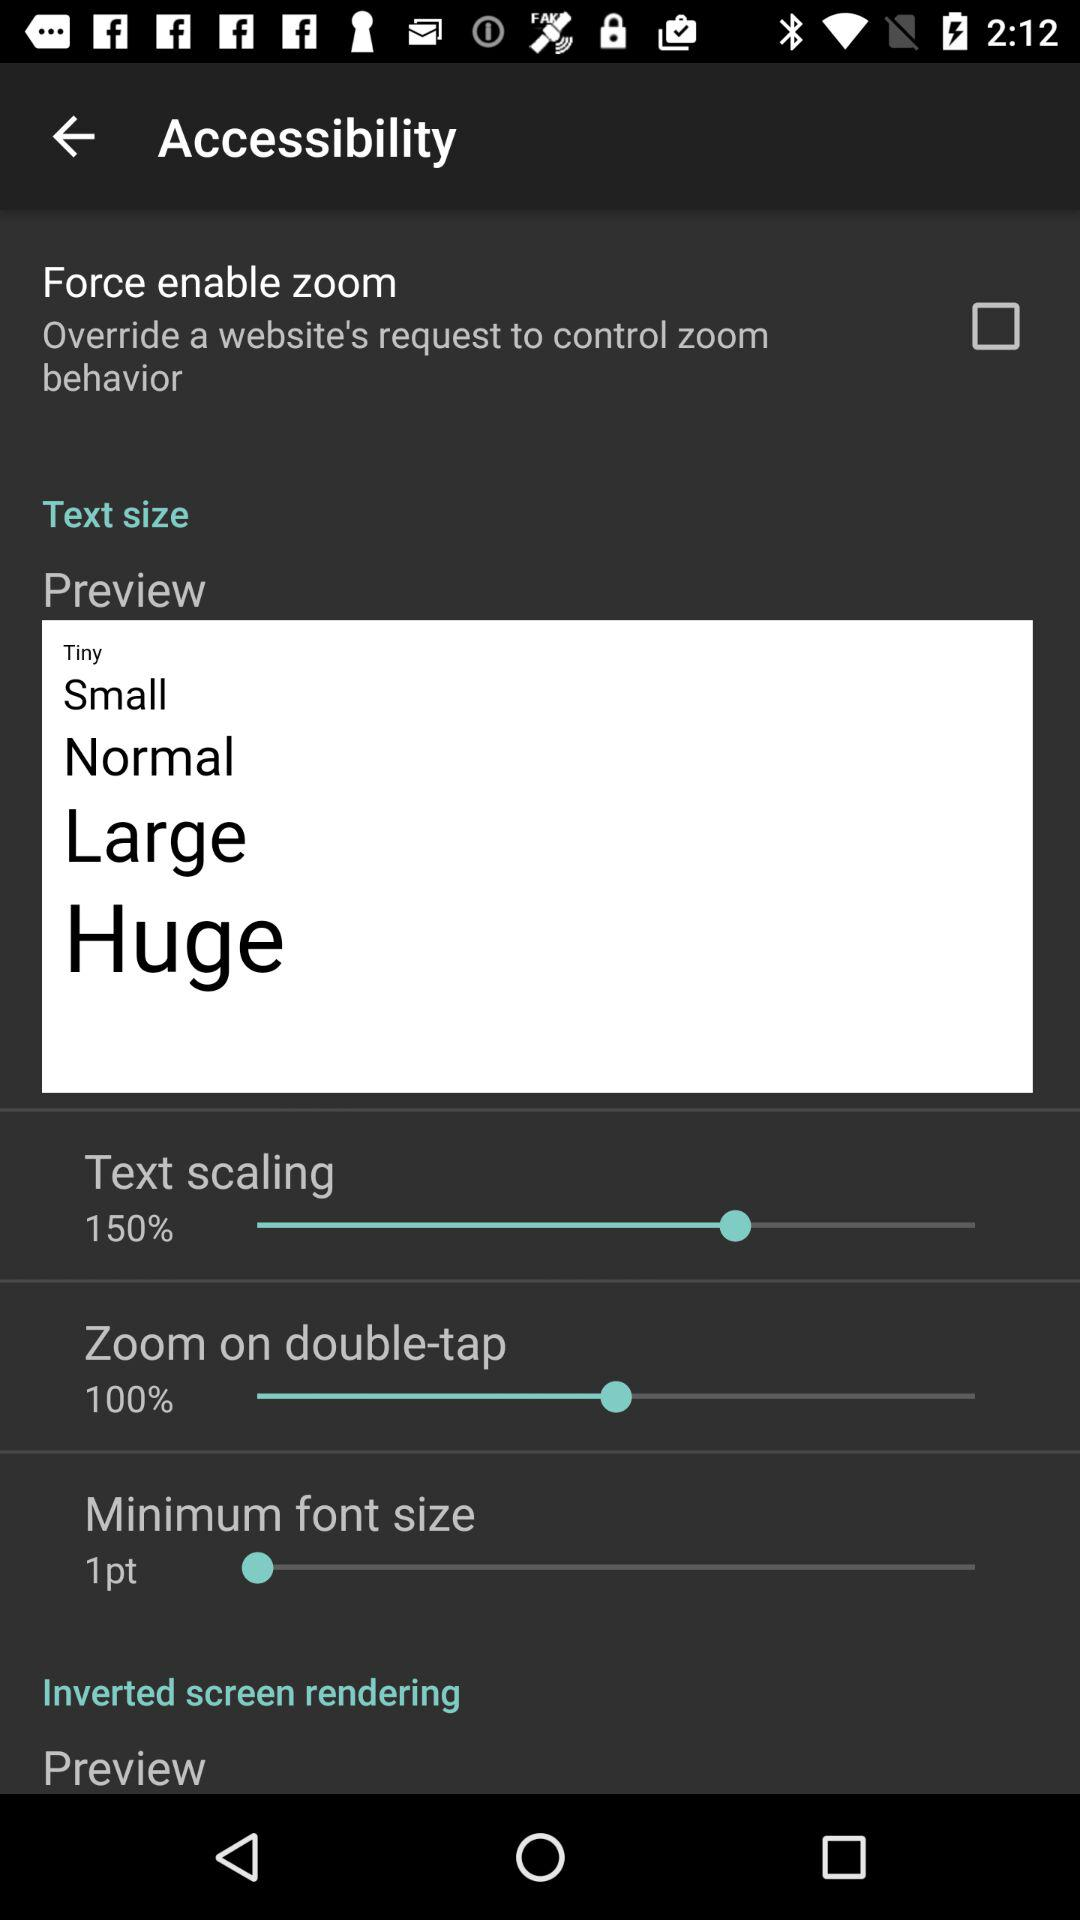What is the status of "Force enable zoom"? The status is "off". 